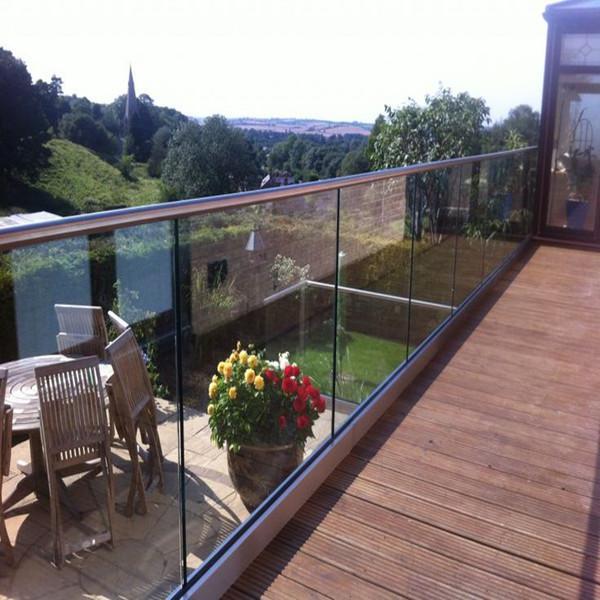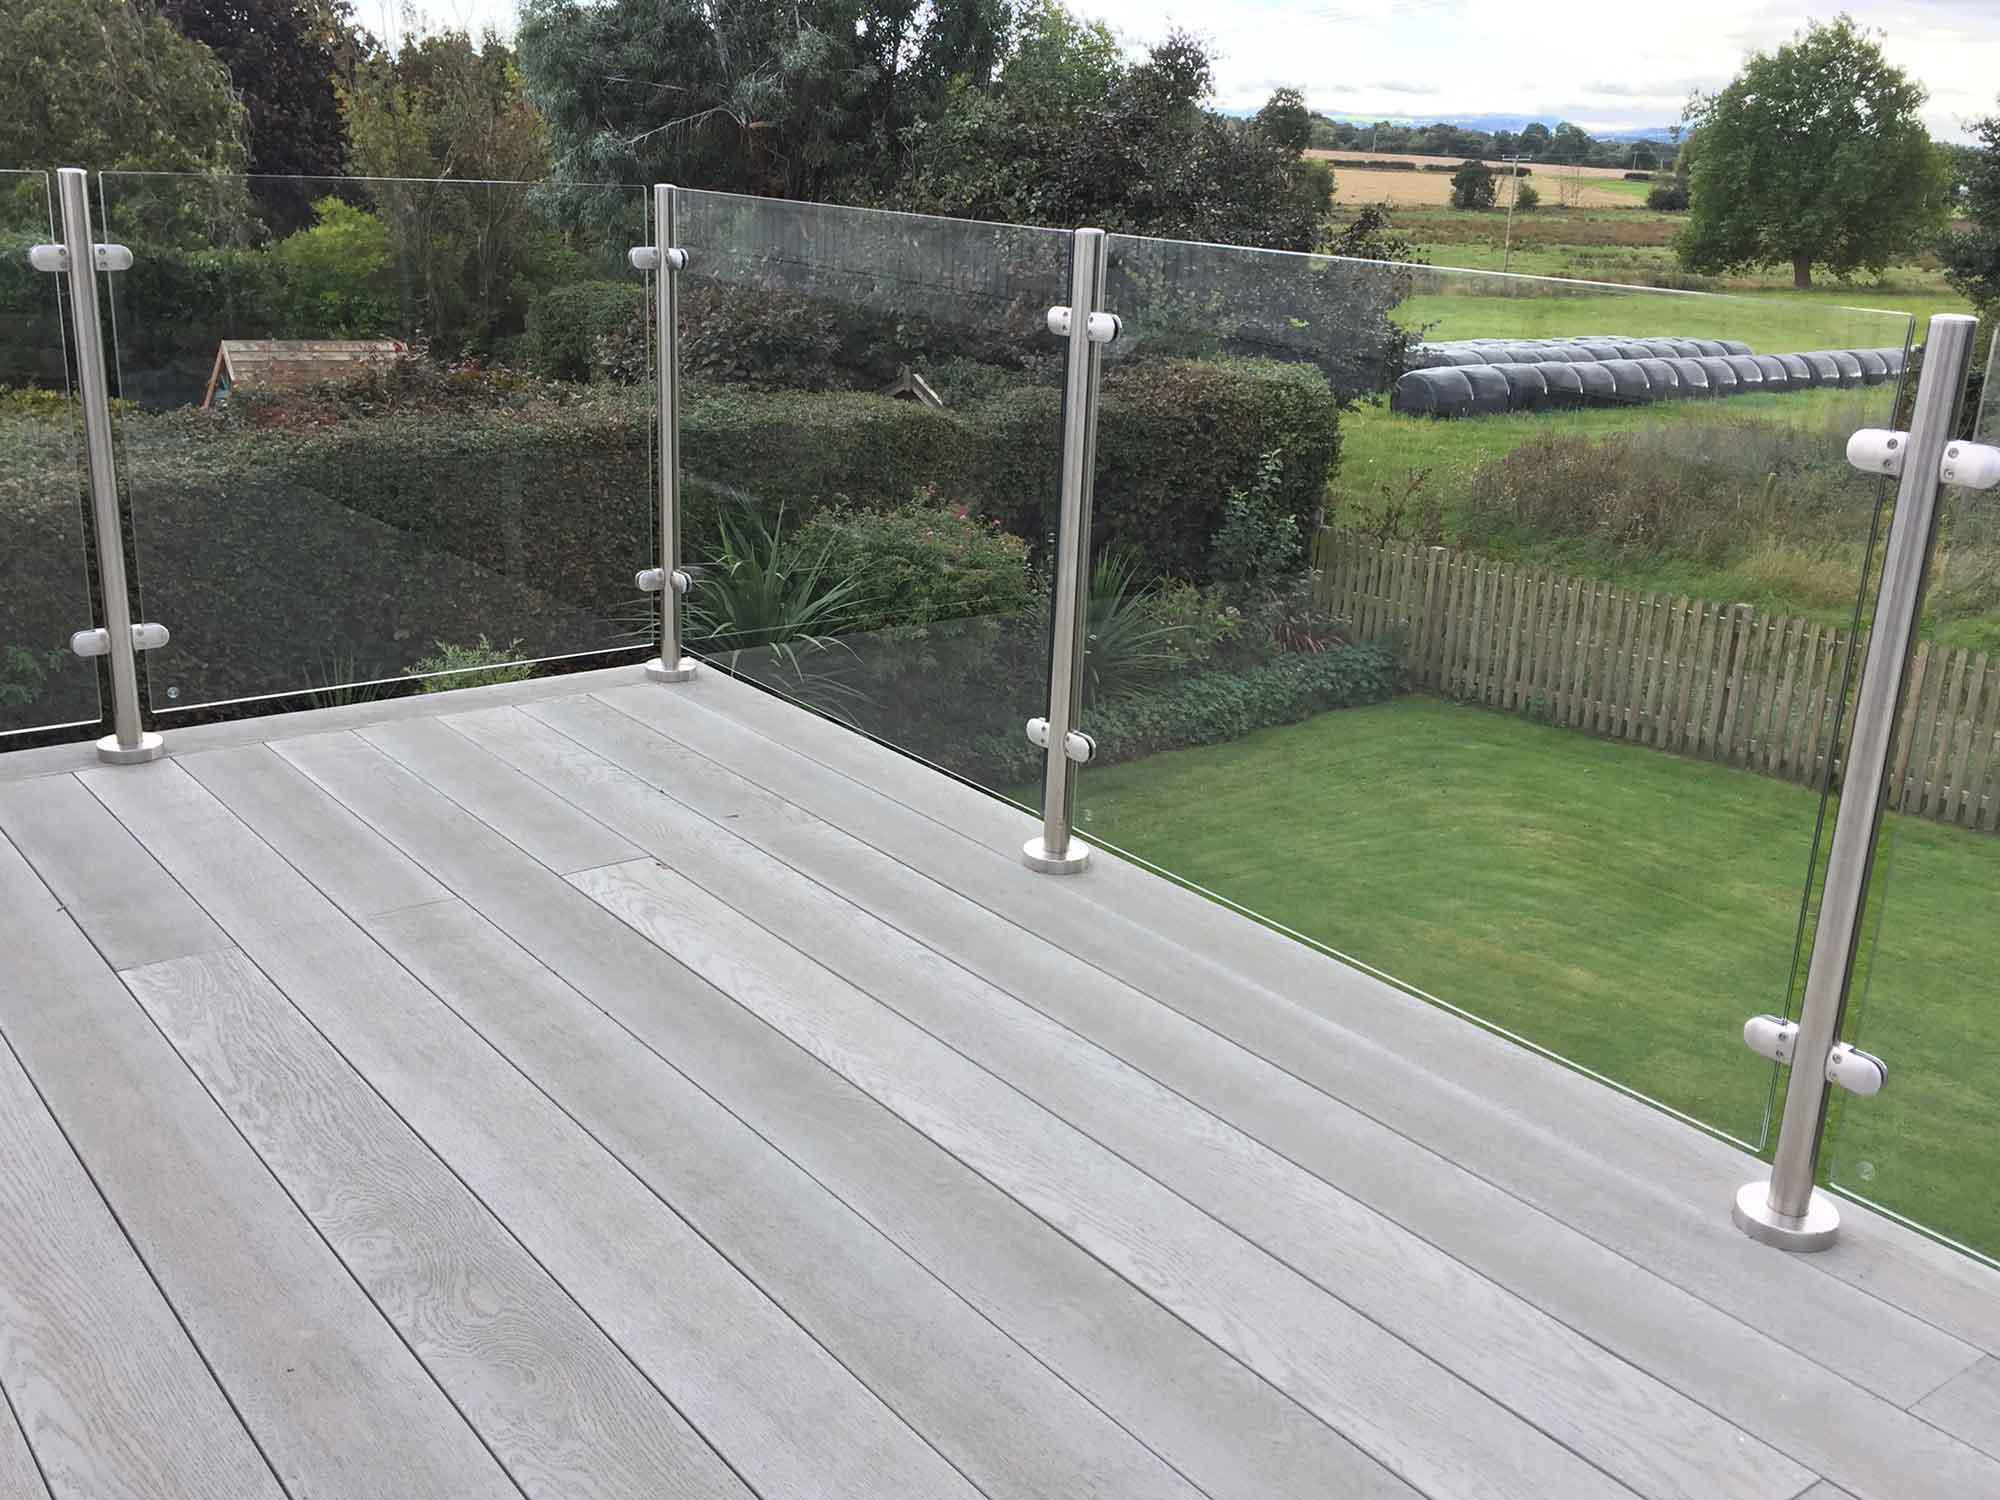The first image is the image on the left, the second image is the image on the right. Given the left and right images, does the statement "In each image, a glass-paneled balcony overlooks an area of green grass, and one of the balconies pictured has a top rail on the glass panels but the other does not." hold true? Answer yes or no. Yes. 